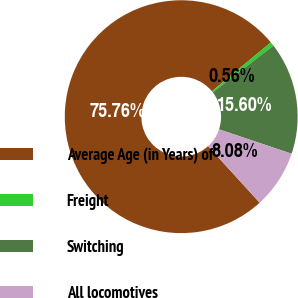Convert chart. <chart><loc_0><loc_0><loc_500><loc_500><pie_chart><fcel>Average Age (in Years) of<fcel>Freight<fcel>Switching<fcel>All locomotives<nl><fcel>75.75%<fcel>0.56%<fcel>15.6%<fcel>8.08%<nl></chart> 